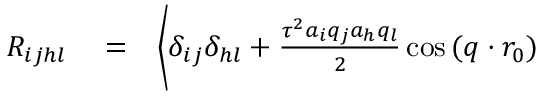Convert formula to latex. <formula><loc_0><loc_0><loc_500><loc_500>\begin{array} { r l r } { R _ { i j h l } } & = } & { \Big \langle \delta _ { i j } \delta _ { h l } + \frac { \tau ^ { 2 } a _ { i } q _ { j } a _ { h } q _ { l } } { 2 } \cos { ( q \cdot r _ { 0 } ) } } \end{array}</formula> 